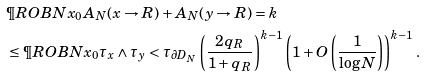<formula> <loc_0><loc_0><loc_500><loc_500>& \P R O B { N x _ { 0 } } { A _ { N } ( x \to R ) + A _ { N } ( y \to R ) = k } \\ & \leq \P R O B { N x _ { 0 } } { \tau _ { x } \wedge \tau _ { y } < \tau _ { \partial D _ { N } } } \left ( \frac { 2 q _ { R } } { 1 + q _ { R } } \right ) ^ { k - 1 } \left ( 1 + O \left ( \frac { 1 } { \log N } \right ) \right ) ^ { k - 1 } .</formula> 